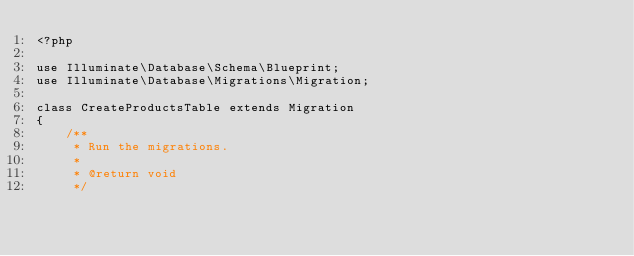Convert code to text. <code><loc_0><loc_0><loc_500><loc_500><_PHP_><?php

use Illuminate\Database\Schema\Blueprint;
use Illuminate\Database\Migrations\Migration;

class CreateProductsTable extends Migration
{
    /**
     * Run the migrations.
     *
     * @return void
     */</code> 